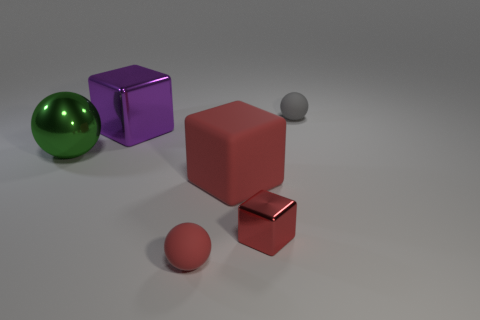Subtract all yellow cylinders. How many red cubes are left? 2 Subtract all big red matte blocks. How many blocks are left? 2 Subtract 1 blocks. How many blocks are left? 2 Add 2 purple shiny blocks. How many objects exist? 8 Subtract 0 green cubes. How many objects are left? 6 Subtract all red metal cylinders. Subtract all purple shiny things. How many objects are left? 5 Add 4 large shiny spheres. How many large shiny spheres are left? 5 Add 2 large cyan rubber things. How many large cyan rubber things exist? 2 